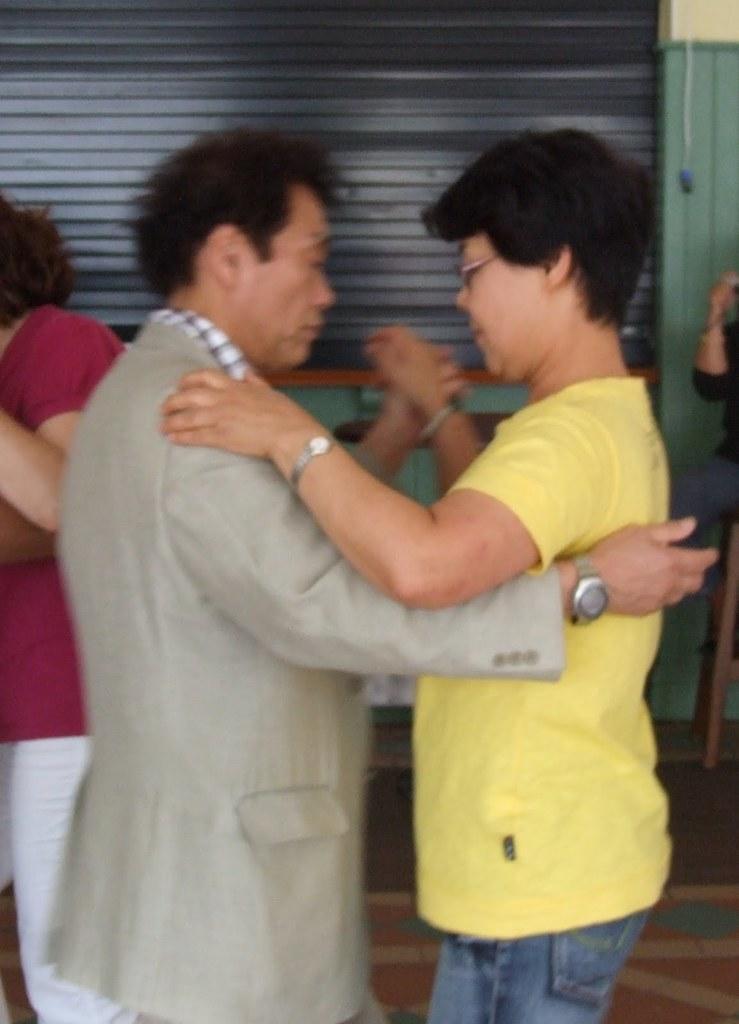Please provide a concise description of this image. In this image we can see a man and a woman holding each other. Both are wearing watch. And the lady is wearing specs. In the back there is a wall. Also there is a person on the left side. And there is another person on the right side. 